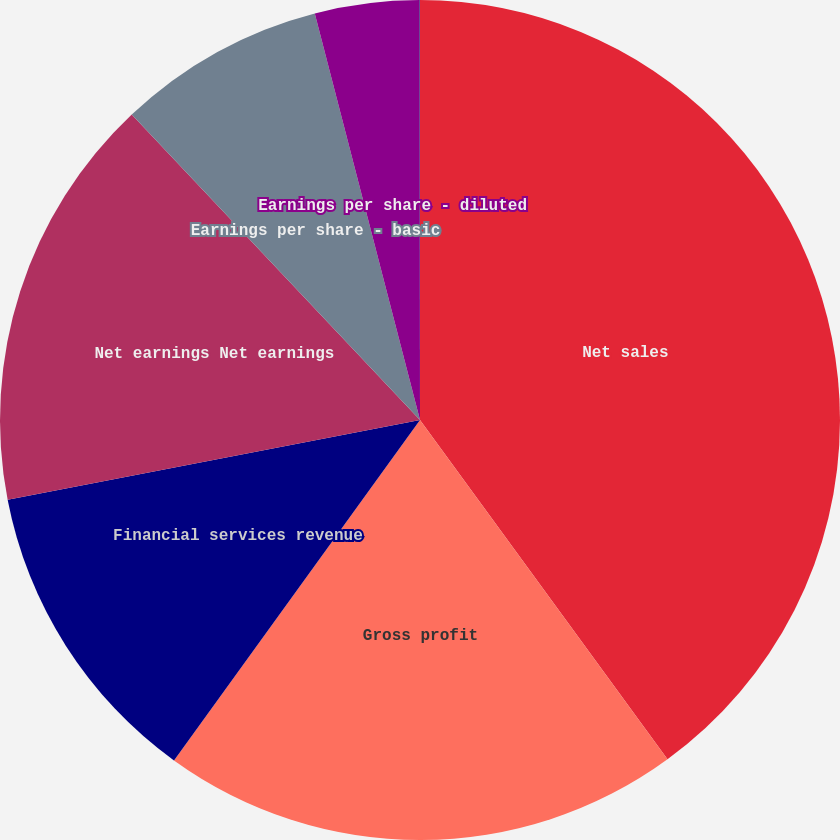<chart> <loc_0><loc_0><loc_500><loc_500><pie_chart><fcel>Net sales<fcel>Gross profit<fcel>Financial services revenue<fcel>Net earnings Net earnings<fcel>Earnings per share - basic<fcel>Earnings per share - diluted<fcel>Cash dividends paid per share<nl><fcel>39.97%<fcel>19.99%<fcel>12.0%<fcel>16.0%<fcel>8.01%<fcel>4.01%<fcel>0.02%<nl></chart> 